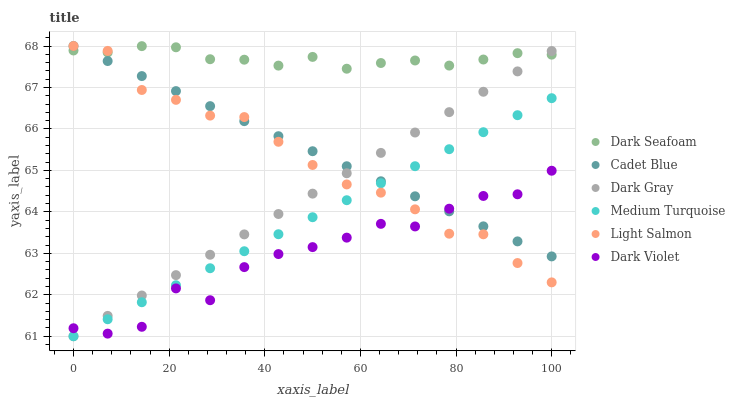Does Dark Violet have the minimum area under the curve?
Answer yes or no. Yes. Does Dark Seafoam have the maximum area under the curve?
Answer yes or no. Yes. Does Cadet Blue have the minimum area under the curve?
Answer yes or no. No. Does Cadet Blue have the maximum area under the curve?
Answer yes or no. No. Is Cadet Blue the smoothest?
Answer yes or no. Yes. Is Dark Violet the roughest?
Answer yes or no. Yes. Is Dark Violet the smoothest?
Answer yes or no. No. Is Cadet Blue the roughest?
Answer yes or no. No. Does Dark Gray have the lowest value?
Answer yes or no. Yes. Does Cadet Blue have the lowest value?
Answer yes or no. No. Does Cadet Blue have the highest value?
Answer yes or no. Yes. Does Dark Violet have the highest value?
Answer yes or no. No. Is Medium Turquoise less than Dark Seafoam?
Answer yes or no. Yes. Is Dark Seafoam greater than Medium Turquoise?
Answer yes or no. Yes. Does Cadet Blue intersect Light Salmon?
Answer yes or no. Yes. Is Cadet Blue less than Light Salmon?
Answer yes or no. No. Is Cadet Blue greater than Light Salmon?
Answer yes or no. No. Does Medium Turquoise intersect Dark Seafoam?
Answer yes or no. No. 